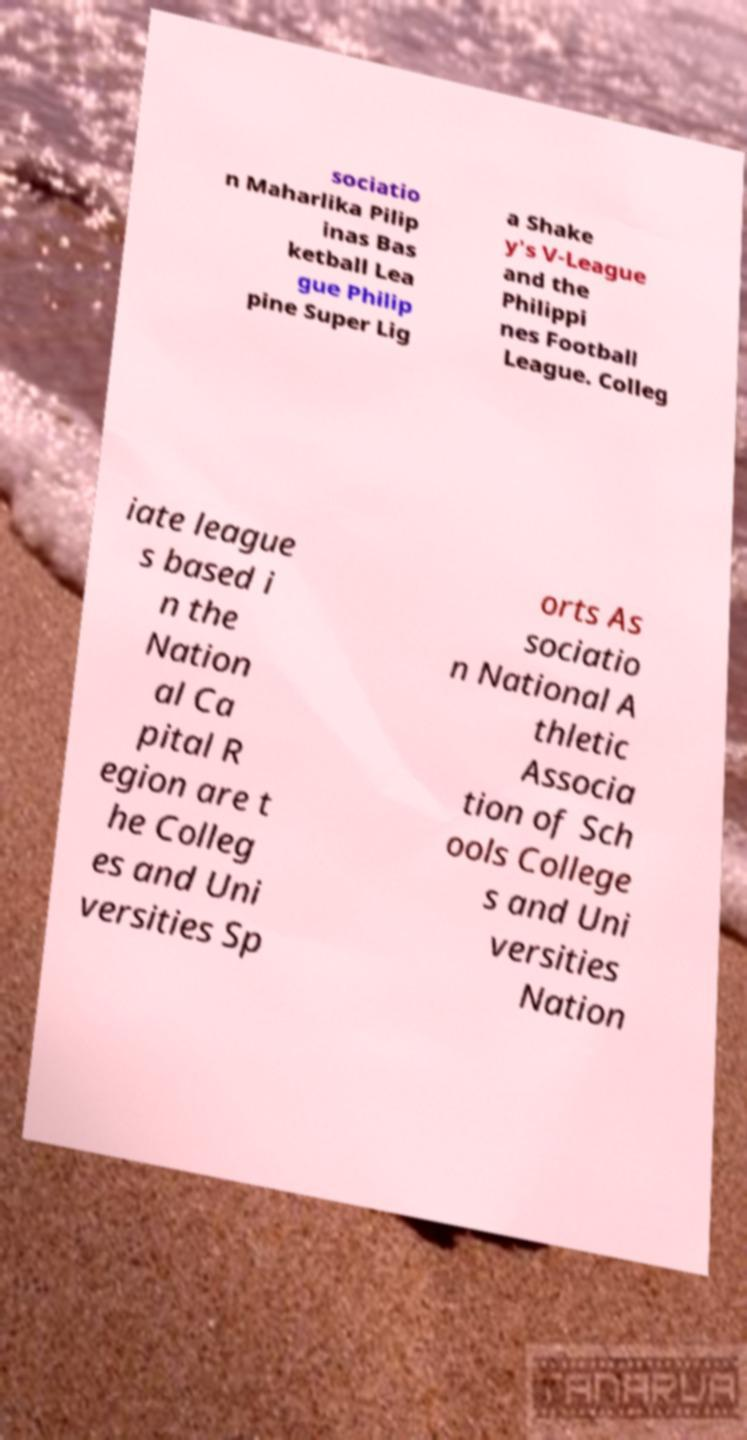Please identify and transcribe the text found in this image. sociatio n Maharlika Pilip inas Bas ketball Lea gue Philip pine Super Lig a Shake y's V-League and the Philippi nes Football League. Colleg iate league s based i n the Nation al Ca pital R egion are t he Colleg es and Uni versities Sp orts As sociatio n National A thletic Associa tion of Sch ools College s and Uni versities Nation 